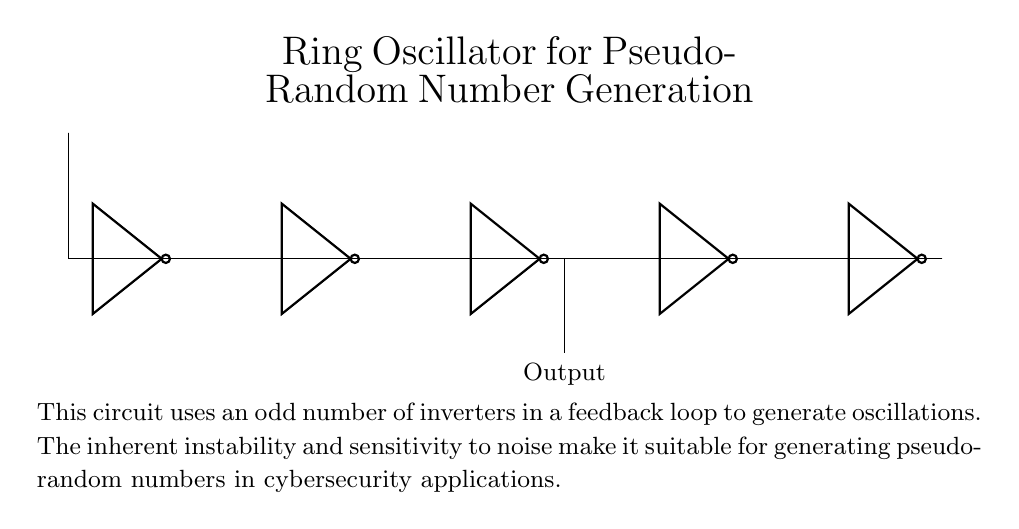What components are used in the circuit? The circuit contains five NOT gates, which are symbolized by 'not' blocks in the diagram. Each NOT gate is represented as an inverter, and they are connected in series to form the ring oscillator.
Answer: five NOT gates What is the output of the oscillator? The output is taken from the second NOT gate (not3) in the feedback loop, as indicated by the connection leading down from it. This output can be interpreted as the generated pseudo-random number.
Answer: Output How are the NOT gates connected? The NOT gates are connected in a series loop where the output of one gate feeds into the input of the next gate, culminating back to the first, indicating a complete cycle. This feedback creates the oscillation necessary for pseudo-random number generation.
Answer: in series with feedback How does this circuit generate pseudo-random numbers? The circuit generates pseudo-random numbers due to its inherent instability and sensitivity to noise. By using an odd number of NOT gates, the feedback loop introduces unpredictability to the output signal, critical for random number generation.
Answer: instability and feedback Why is an odd number of inverters used? An odd number of inverters is essential to ensure that there is a phase shift in the feedback loop, preventing the circuit from settling into a stable state, which keeps the oscillation going and aids in generating pseudo-random values.
Answer: to maintain oscillation What type of oscillator is this circuit? This circuit is a ring oscillator, as it consists of a closed-loop of gates that produces oscillating signals, which can be harnessed for applications like generating pseudo-random numbers in cybersecurity.
Answer: ring oscillator 